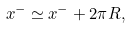Convert formula to latex. <formula><loc_0><loc_0><loc_500><loc_500>x ^ { - } \simeq x ^ { - } + 2 \pi R ,</formula> 